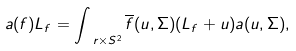Convert formula to latex. <formula><loc_0><loc_0><loc_500><loc_500>a ( f ) L _ { f } = \int _ { \ r \times S ^ { 2 } } \overline { f } ( u , \Sigma ) ( L _ { f } + u ) a ( u , \Sigma ) ,</formula> 